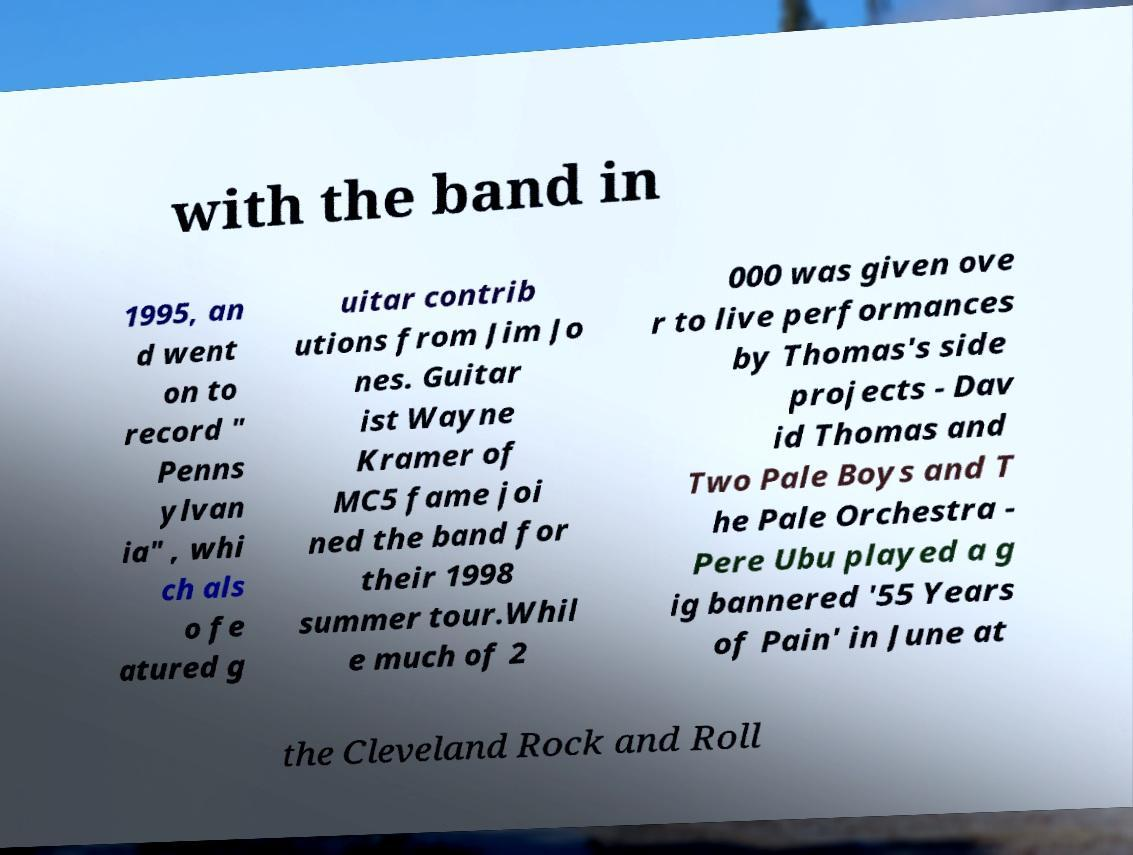I need the written content from this picture converted into text. Can you do that? with the band in 1995, an d went on to record " Penns ylvan ia" , whi ch als o fe atured g uitar contrib utions from Jim Jo nes. Guitar ist Wayne Kramer of MC5 fame joi ned the band for their 1998 summer tour.Whil e much of 2 000 was given ove r to live performances by Thomas's side projects - Dav id Thomas and Two Pale Boys and T he Pale Orchestra - Pere Ubu played a g ig bannered '55 Years of Pain' in June at the Cleveland Rock and Roll 